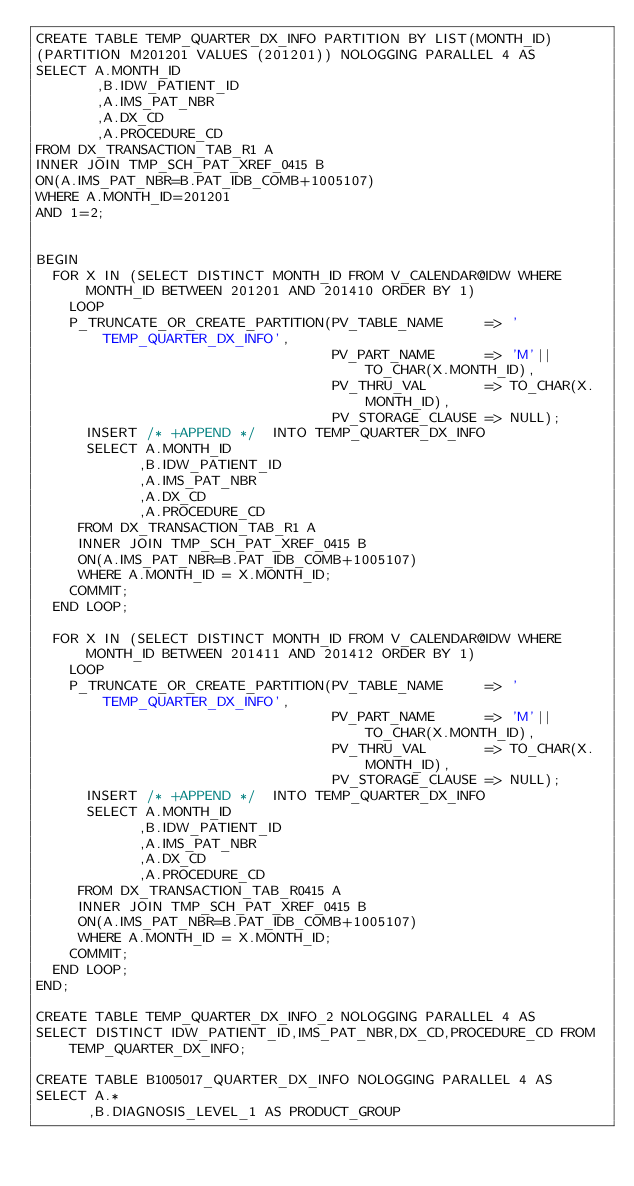Convert code to text. <code><loc_0><loc_0><loc_500><loc_500><_SQL_>CREATE TABLE TEMP_QUARTER_DX_INFO PARTITION BY LIST(MONTH_ID)
(PARTITION M201201 VALUES (201201)) NOLOGGING PARALLEL 4 AS
SELECT A.MONTH_ID
       ,B.IDW_PATIENT_ID
       ,A.IMS_PAT_NBR
       ,A.DX_CD
       ,A.PROCEDURE_CD
FROM DX_TRANSACTION_TAB_R1 A
INNER JOIN TMP_SCH_PAT_XREF_0415 B
ON(A.IMS_PAT_NBR=B.PAT_IDB_COMB+1005107)
WHERE A.MONTH_ID=201201
AND 1=2;


BEGIN
  FOR X IN (SELECT DISTINCT MONTH_ID FROM V_CALENDAR@IDW WHERE MONTH_ID BETWEEN 201201 AND 201410 ORDER BY 1)
    LOOP
    P_TRUNCATE_OR_CREATE_PARTITION(PV_TABLE_NAME     => 'TEMP_QUARTER_DX_INFO',
                                   PV_PART_NAME      => 'M'||TO_CHAR(X.MONTH_ID),
                                   PV_THRU_VAL       => TO_CHAR(X.MONTH_ID),
                                   PV_STORAGE_CLAUSE => NULL);
      INSERT /* +APPEND */  INTO TEMP_QUARTER_DX_INFO
      SELECT A.MONTH_ID
            ,B.IDW_PATIENT_ID
            ,A.IMS_PAT_NBR
            ,A.DX_CD
            ,A.PROCEDURE_CD
     FROM DX_TRANSACTION_TAB_R1 A
     INNER JOIN TMP_SCH_PAT_XREF_0415 B
     ON(A.IMS_PAT_NBR=B.PAT_IDB_COMB+1005107)
     WHERE A.MONTH_ID = X.MONTH_ID;
    COMMIT;
  END LOOP;
  
  FOR X IN (SELECT DISTINCT MONTH_ID FROM V_CALENDAR@IDW WHERE MONTH_ID BETWEEN 201411 AND 201412 ORDER BY 1)
    LOOP
    P_TRUNCATE_OR_CREATE_PARTITION(PV_TABLE_NAME     => 'TEMP_QUARTER_DX_INFO',
                                   PV_PART_NAME      => 'M'||TO_CHAR(X.MONTH_ID),
                                   PV_THRU_VAL       => TO_CHAR(X.MONTH_ID),
                                   PV_STORAGE_CLAUSE => NULL);
      INSERT /* +APPEND */  INTO TEMP_QUARTER_DX_INFO
      SELECT A.MONTH_ID
            ,B.IDW_PATIENT_ID
            ,A.IMS_PAT_NBR
            ,A.DX_CD
            ,A.PROCEDURE_CD
     FROM DX_TRANSACTION_TAB_R0415 A
     INNER JOIN TMP_SCH_PAT_XREF_0415 B
     ON(A.IMS_PAT_NBR=B.PAT_IDB_COMB+1005107)
     WHERE A.MONTH_ID = X.MONTH_ID;
    COMMIT;
  END LOOP;
END;

CREATE TABLE TEMP_QUARTER_DX_INFO_2 NOLOGGING PARALLEL 4 AS
SELECT DISTINCT IDW_PATIENT_ID,IMS_PAT_NBR,DX_CD,PROCEDURE_CD FROM TEMP_QUARTER_DX_INFO;

CREATE TABLE B1005017_QUARTER_DX_INFO NOLOGGING PARALLEL 4 AS
SELECT A.*
      ,B.DIAGNOSIS_LEVEL_1 AS PRODUCT_GROUP</code> 